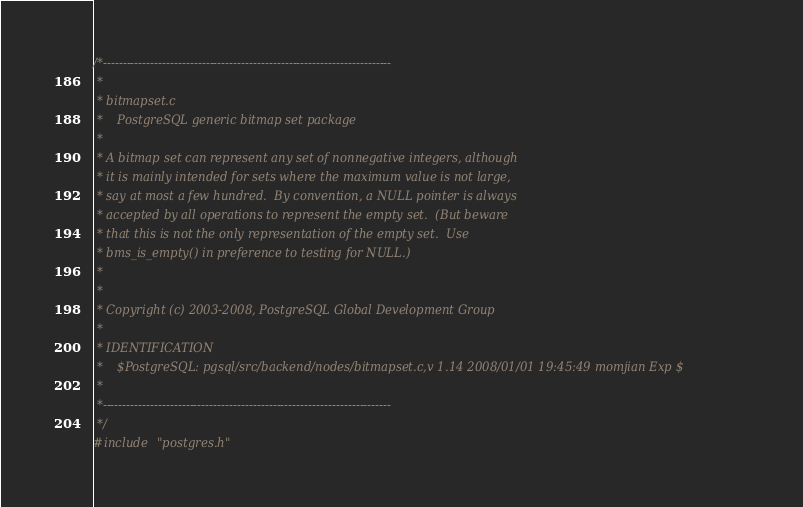Convert code to text. <code><loc_0><loc_0><loc_500><loc_500><_C_>/*-------------------------------------------------------------------------
 *
 * bitmapset.c
 *	  PostgreSQL generic bitmap set package
 *
 * A bitmap set can represent any set of nonnegative integers, although
 * it is mainly intended for sets where the maximum value is not large,
 * say at most a few hundred.  By convention, a NULL pointer is always
 * accepted by all operations to represent the empty set.  (But beware
 * that this is not the only representation of the empty set.  Use
 * bms_is_empty() in preference to testing for NULL.)
 *
 *
 * Copyright (c) 2003-2008, PostgreSQL Global Development Group
 *
 * IDENTIFICATION
 *	  $PostgreSQL: pgsql/src/backend/nodes/bitmapset.c,v 1.14 2008/01/01 19:45:49 momjian Exp $
 *
 *-------------------------------------------------------------------------
 */
#include "postgres.h"
</code> 